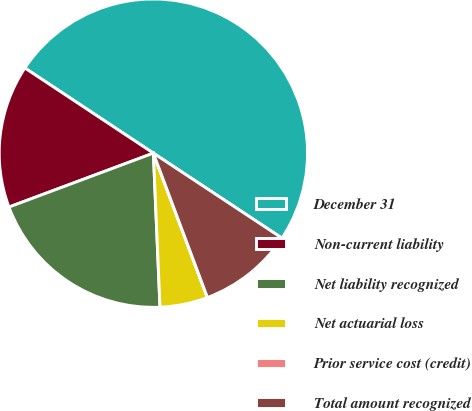Convert chart to OTSL. <chart><loc_0><loc_0><loc_500><loc_500><pie_chart><fcel>December 31<fcel>Non-current liability<fcel>Net liability recognized<fcel>Net actuarial loss<fcel>Prior service cost (credit)<fcel>Total amount recognized<nl><fcel>49.98%<fcel>15.0%<fcel>20.0%<fcel>5.01%<fcel>0.01%<fcel>10.0%<nl></chart> 